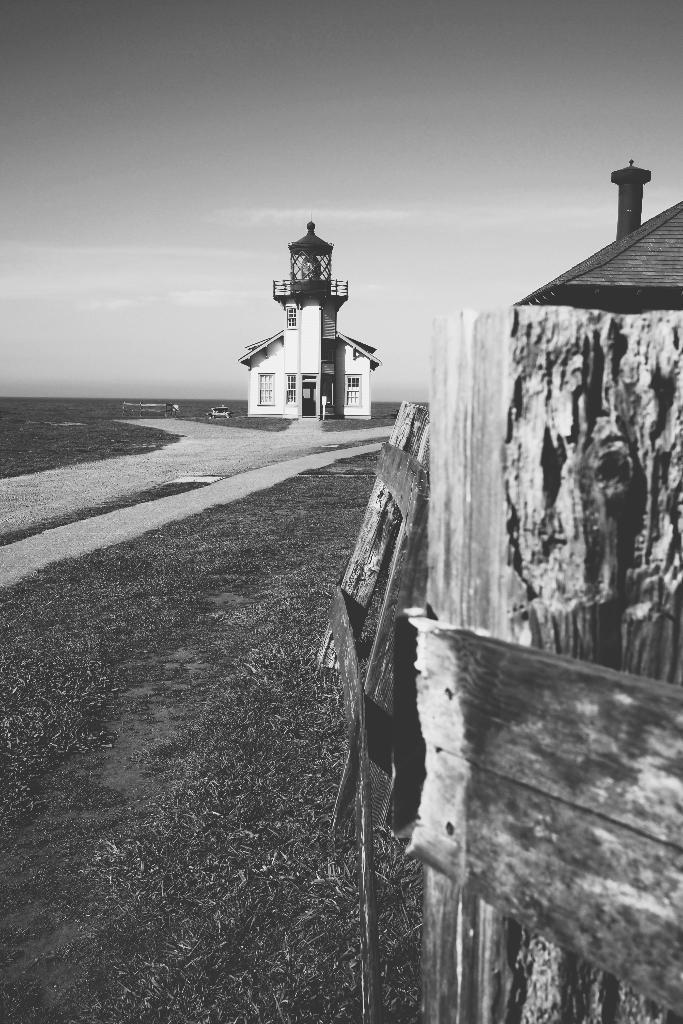What type of structures can be seen in the image? There are buildings in the image. What architectural feature is present in the image? There is wooden fencing in the image. What can be seen in the buildings? There are windows in the image. What is the color scheme of the image? The image is in black and white. Where is the playground located in the image? There is no playground present in the image. What type of frog can be seen sitting on the windowsill in the image? There is no frog present in the image. 